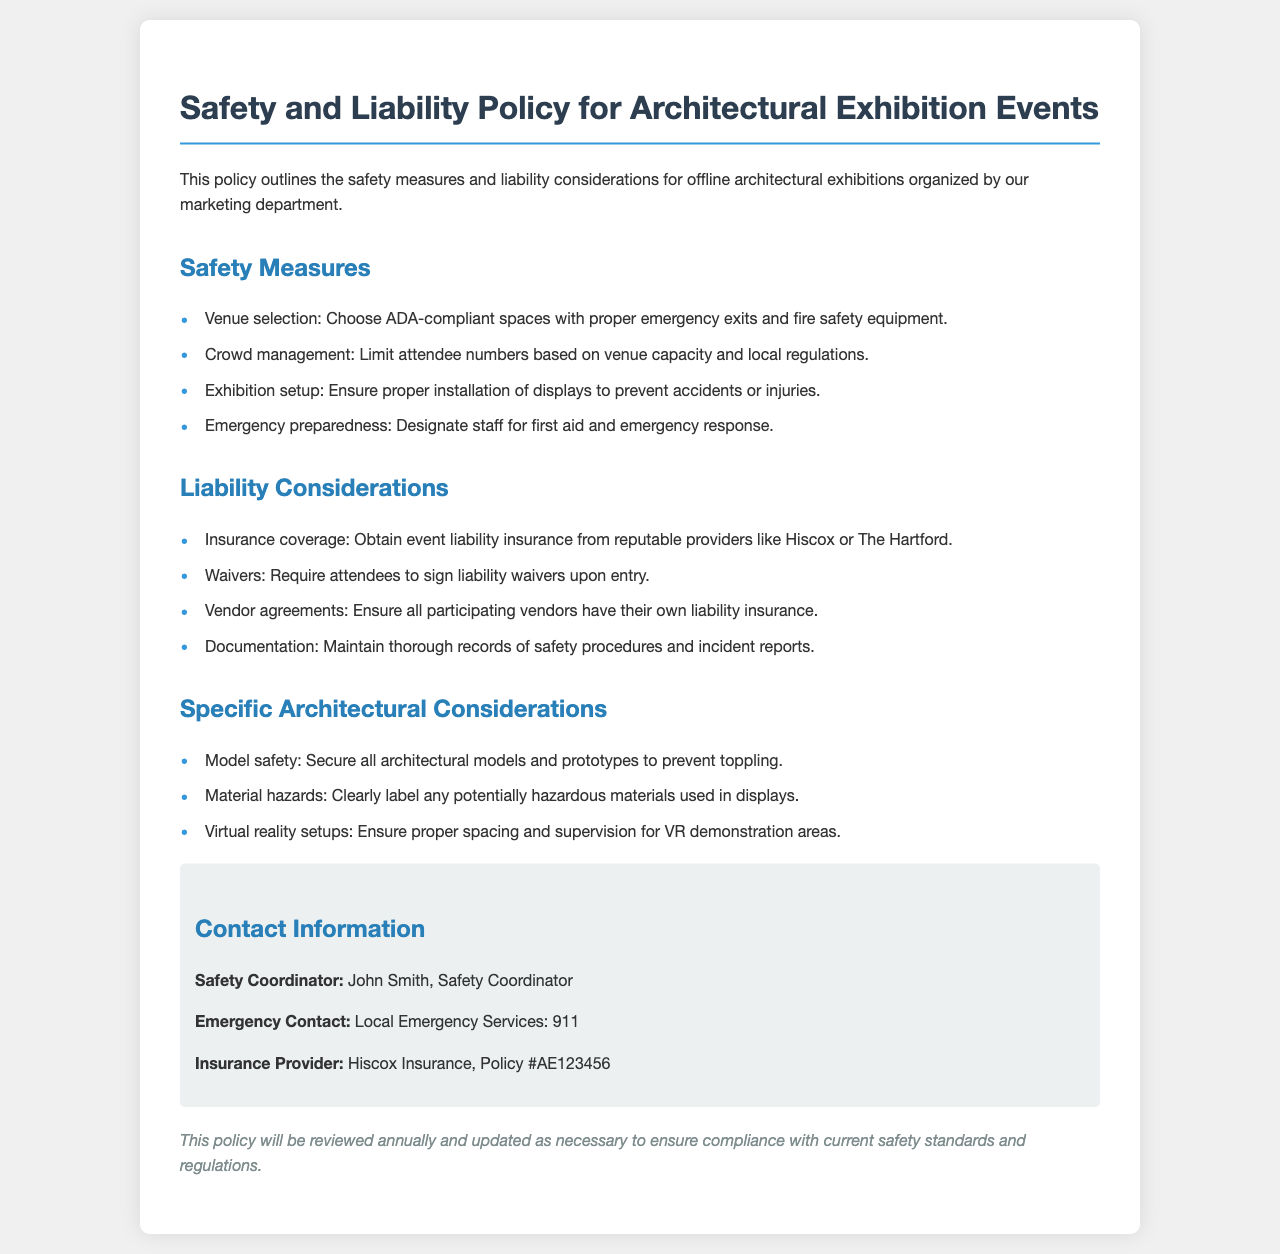What are the main safety measures? The document lists four key safety measures that must be followed during the exhibitions.
Answer: Venue selection, Crowd management, Exhibition setup, Emergency preparedness How many liability considerations are there? The section on liability considerations contains four specific points.
Answer: Four Who is the safety coordinator? The contact information section specifies the person responsible for safety at the events.
Answer: John Smith What type of insurance must be obtained? The document specifies the type of insurance coverage required for the events.
Answer: Event liability insurance What should attendees sign upon entry? The policy states that attendees must sign a specific legal document during their participation.
Answer: Liability waivers What is required for all participating vendors? According to the liability considerations, there is a requirement vendors must adhere to regarding insurance.
Answer: Their own liability insurance What specific safety measure is related to architectural models? This consideration focuses on securing a particular type of exhibition element in the event space.
Answer: Model safety What is the emergency contact number provided? The policy document includes an important contact number for emergencies.
Answer: 911 